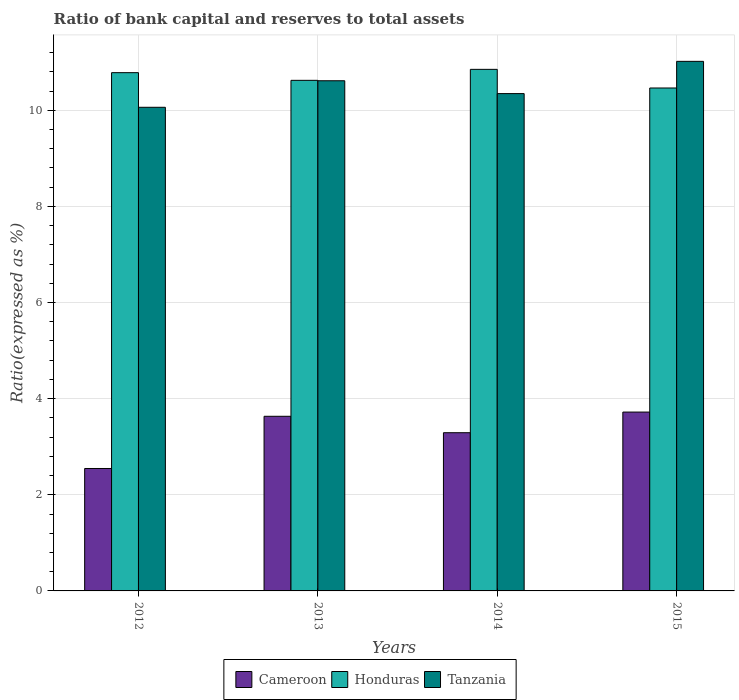How many different coloured bars are there?
Keep it short and to the point. 3. Are the number of bars per tick equal to the number of legend labels?
Ensure brevity in your answer.  Yes. How many bars are there on the 4th tick from the right?
Your answer should be compact. 3. What is the label of the 2nd group of bars from the left?
Offer a terse response. 2013. What is the ratio of bank capital and reserves to total assets in Honduras in 2014?
Provide a succinct answer. 10.85. Across all years, what is the maximum ratio of bank capital and reserves to total assets in Honduras?
Give a very brief answer. 10.85. Across all years, what is the minimum ratio of bank capital and reserves to total assets in Honduras?
Make the answer very short. 10.46. In which year was the ratio of bank capital and reserves to total assets in Tanzania maximum?
Make the answer very short. 2015. In which year was the ratio of bank capital and reserves to total assets in Honduras minimum?
Your answer should be very brief. 2015. What is the total ratio of bank capital and reserves to total assets in Cameroon in the graph?
Ensure brevity in your answer.  13.19. What is the difference between the ratio of bank capital and reserves to total assets in Honduras in 2012 and that in 2015?
Your response must be concise. 0.32. What is the difference between the ratio of bank capital and reserves to total assets in Cameroon in 2015 and the ratio of bank capital and reserves to total assets in Tanzania in 2014?
Offer a very short reply. -6.63. What is the average ratio of bank capital and reserves to total assets in Tanzania per year?
Your answer should be compact. 10.51. In the year 2012, what is the difference between the ratio of bank capital and reserves to total assets in Cameroon and ratio of bank capital and reserves to total assets in Honduras?
Offer a terse response. -8.23. What is the ratio of the ratio of bank capital and reserves to total assets in Tanzania in 2013 to that in 2014?
Offer a terse response. 1.03. What is the difference between the highest and the second highest ratio of bank capital and reserves to total assets in Cameroon?
Ensure brevity in your answer.  0.09. What is the difference between the highest and the lowest ratio of bank capital and reserves to total assets in Honduras?
Ensure brevity in your answer.  0.39. In how many years, is the ratio of bank capital and reserves to total assets in Honduras greater than the average ratio of bank capital and reserves to total assets in Honduras taken over all years?
Your answer should be compact. 2. What does the 1st bar from the left in 2014 represents?
Give a very brief answer. Cameroon. What does the 1st bar from the right in 2012 represents?
Offer a terse response. Tanzania. How many bars are there?
Provide a short and direct response. 12. Are the values on the major ticks of Y-axis written in scientific E-notation?
Offer a terse response. No. Does the graph contain any zero values?
Offer a terse response. No. Where does the legend appear in the graph?
Your answer should be compact. Bottom center. How are the legend labels stacked?
Your answer should be compact. Horizontal. What is the title of the graph?
Give a very brief answer. Ratio of bank capital and reserves to total assets. What is the label or title of the Y-axis?
Provide a short and direct response. Ratio(expressed as %). What is the Ratio(expressed as %) of Cameroon in 2012?
Make the answer very short. 2.55. What is the Ratio(expressed as %) in Honduras in 2012?
Offer a very short reply. 10.78. What is the Ratio(expressed as %) of Tanzania in 2012?
Offer a very short reply. 10.06. What is the Ratio(expressed as %) in Cameroon in 2013?
Provide a succinct answer. 3.63. What is the Ratio(expressed as %) in Honduras in 2013?
Your response must be concise. 10.62. What is the Ratio(expressed as %) of Tanzania in 2013?
Your answer should be compact. 10.61. What is the Ratio(expressed as %) of Cameroon in 2014?
Your answer should be very brief. 3.29. What is the Ratio(expressed as %) in Honduras in 2014?
Give a very brief answer. 10.85. What is the Ratio(expressed as %) in Tanzania in 2014?
Your answer should be compact. 10.35. What is the Ratio(expressed as %) in Cameroon in 2015?
Provide a short and direct response. 3.72. What is the Ratio(expressed as %) in Honduras in 2015?
Offer a terse response. 10.46. What is the Ratio(expressed as %) of Tanzania in 2015?
Offer a very short reply. 11.02. Across all years, what is the maximum Ratio(expressed as %) of Cameroon?
Give a very brief answer. 3.72. Across all years, what is the maximum Ratio(expressed as %) of Honduras?
Offer a terse response. 10.85. Across all years, what is the maximum Ratio(expressed as %) in Tanzania?
Provide a succinct answer. 11.02. Across all years, what is the minimum Ratio(expressed as %) of Cameroon?
Make the answer very short. 2.55. Across all years, what is the minimum Ratio(expressed as %) in Honduras?
Provide a short and direct response. 10.46. Across all years, what is the minimum Ratio(expressed as %) in Tanzania?
Provide a succinct answer. 10.06. What is the total Ratio(expressed as %) in Cameroon in the graph?
Keep it short and to the point. 13.19. What is the total Ratio(expressed as %) of Honduras in the graph?
Make the answer very short. 42.72. What is the total Ratio(expressed as %) in Tanzania in the graph?
Provide a short and direct response. 42.04. What is the difference between the Ratio(expressed as %) of Cameroon in 2012 and that in 2013?
Your answer should be compact. -1.09. What is the difference between the Ratio(expressed as %) in Honduras in 2012 and that in 2013?
Your response must be concise. 0.16. What is the difference between the Ratio(expressed as %) in Tanzania in 2012 and that in 2013?
Make the answer very short. -0.55. What is the difference between the Ratio(expressed as %) of Cameroon in 2012 and that in 2014?
Provide a short and direct response. -0.74. What is the difference between the Ratio(expressed as %) in Honduras in 2012 and that in 2014?
Ensure brevity in your answer.  -0.07. What is the difference between the Ratio(expressed as %) of Tanzania in 2012 and that in 2014?
Ensure brevity in your answer.  -0.28. What is the difference between the Ratio(expressed as %) of Cameroon in 2012 and that in 2015?
Keep it short and to the point. -1.17. What is the difference between the Ratio(expressed as %) in Honduras in 2012 and that in 2015?
Your response must be concise. 0.32. What is the difference between the Ratio(expressed as %) of Tanzania in 2012 and that in 2015?
Your response must be concise. -0.96. What is the difference between the Ratio(expressed as %) of Cameroon in 2013 and that in 2014?
Provide a succinct answer. 0.34. What is the difference between the Ratio(expressed as %) of Honduras in 2013 and that in 2014?
Provide a short and direct response. -0.23. What is the difference between the Ratio(expressed as %) of Tanzania in 2013 and that in 2014?
Your answer should be compact. 0.27. What is the difference between the Ratio(expressed as %) in Cameroon in 2013 and that in 2015?
Offer a very short reply. -0.09. What is the difference between the Ratio(expressed as %) of Honduras in 2013 and that in 2015?
Keep it short and to the point. 0.16. What is the difference between the Ratio(expressed as %) in Tanzania in 2013 and that in 2015?
Your response must be concise. -0.4. What is the difference between the Ratio(expressed as %) of Cameroon in 2014 and that in 2015?
Give a very brief answer. -0.43. What is the difference between the Ratio(expressed as %) of Honduras in 2014 and that in 2015?
Your answer should be very brief. 0.39. What is the difference between the Ratio(expressed as %) of Tanzania in 2014 and that in 2015?
Your answer should be compact. -0.67. What is the difference between the Ratio(expressed as %) of Cameroon in 2012 and the Ratio(expressed as %) of Honduras in 2013?
Make the answer very short. -8.08. What is the difference between the Ratio(expressed as %) in Cameroon in 2012 and the Ratio(expressed as %) in Tanzania in 2013?
Provide a short and direct response. -8.07. What is the difference between the Ratio(expressed as %) of Honduras in 2012 and the Ratio(expressed as %) of Tanzania in 2013?
Ensure brevity in your answer.  0.17. What is the difference between the Ratio(expressed as %) of Cameroon in 2012 and the Ratio(expressed as %) of Honduras in 2014?
Your response must be concise. -8.3. What is the difference between the Ratio(expressed as %) in Cameroon in 2012 and the Ratio(expressed as %) in Tanzania in 2014?
Offer a terse response. -7.8. What is the difference between the Ratio(expressed as %) of Honduras in 2012 and the Ratio(expressed as %) of Tanzania in 2014?
Keep it short and to the point. 0.44. What is the difference between the Ratio(expressed as %) of Cameroon in 2012 and the Ratio(expressed as %) of Honduras in 2015?
Give a very brief answer. -7.92. What is the difference between the Ratio(expressed as %) of Cameroon in 2012 and the Ratio(expressed as %) of Tanzania in 2015?
Offer a terse response. -8.47. What is the difference between the Ratio(expressed as %) of Honduras in 2012 and the Ratio(expressed as %) of Tanzania in 2015?
Provide a succinct answer. -0.24. What is the difference between the Ratio(expressed as %) of Cameroon in 2013 and the Ratio(expressed as %) of Honduras in 2014?
Give a very brief answer. -7.22. What is the difference between the Ratio(expressed as %) of Cameroon in 2013 and the Ratio(expressed as %) of Tanzania in 2014?
Ensure brevity in your answer.  -6.71. What is the difference between the Ratio(expressed as %) in Honduras in 2013 and the Ratio(expressed as %) in Tanzania in 2014?
Your answer should be very brief. 0.28. What is the difference between the Ratio(expressed as %) in Cameroon in 2013 and the Ratio(expressed as %) in Honduras in 2015?
Your answer should be compact. -6.83. What is the difference between the Ratio(expressed as %) of Cameroon in 2013 and the Ratio(expressed as %) of Tanzania in 2015?
Provide a succinct answer. -7.38. What is the difference between the Ratio(expressed as %) in Honduras in 2013 and the Ratio(expressed as %) in Tanzania in 2015?
Keep it short and to the point. -0.4. What is the difference between the Ratio(expressed as %) of Cameroon in 2014 and the Ratio(expressed as %) of Honduras in 2015?
Make the answer very short. -7.17. What is the difference between the Ratio(expressed as %) of Cameroon in 2014 and the Ratio(expressed as %) of Tanzania in 2015?
Ensure brevity in your answer.  -7.73. What is the difference between the Ratio(expressed as %) in Honduras in 2014 and the Ratio(expressed as %) in Tanzania in 2015?
Offer a very short reply. -0.17. What is the average Ratio(expressed as %) in Cameroon per year?
Offer a very short reply. 3.3. What is the average Ratio(expressed as %) in Honduras per year?
Your answer should be very brief. 10.68. What is the average Ratio(expressed as %) of Tanzania per year?
Give a very brief answer. 10.51. In the year 2012, what is the difference between the Ratio(expressed as %) of Cameroon and Ratio(expressed as %) of Honduras?
Your answer should be very brief. -8.23. In the year 2012, what is the difference between the Ratio(expressed as %) in Cameroon and Ratio(expressed as %) in Tanzania?
Your response must be concise. -7.51. In the year 2012, what is the difference between the Ratio(expressed as %) of Honduras and Ratio(expressed as %) of Tanzania?
Give a very brief answer. 0.72. In the year 2013, what is the difference between the Ratio(expressed as %) in Cameroon and Ratio(expressed as %) in Honduras?
Ensure brevity in your answer.  -6.99. In the year 2013, what is the difference between the Ratio(expressed as %) of Cameroon and Ratio(expressed as %) of Tanzania?
Ensure brevity in your answer.  -6.98. In the year 2013, what is the difference between the Ratio(expressed as %) of Honduras and Ratio(expressed as %) of Tanzania?
Provide a short and direct response. 0.01. In the year 2014, what is the difference between the Ratio(expressed as %) in Cameroon and Ratio(expressed as %) in Honduras?
Offer a very short reply. -7.56. In the year 2014, what is the difference between the Ratio(expressed as %) of Cameroon and Ratio(expressed as %) of Tanzania?
Keep it short and to the point. -7.05. In the year 2014, what is the difference between the Ratio(expressed as %) of Honduras and Ratio(expressed as %) of Tanzania?
Keep it short and to the point. 0.5. In the year 2015, what is the difference between the Ratio(expressed as %) of Cameroon and Ratio(expressed as %) of Honduras?
Make the answer very short. -6.74. In the year 2015, what is the difference between the Ratio(expressed as %) of Cameroon and Ratio(expressed as %) of Tanzania?
Your answer should be compact. -7.3. In the year 2015, what is the difference between the Ratio(expressed as %) of Honduras and Ratio(expressed as %) of Tanzania?
Ensure brevity in your answer.  -0.55. What is the ratio of the Ratio(expressed as %) of Cameroon in 2012 to that in 2013?
Your answer should be very brief. 0.7. What is the ratio of the Ratio(expressed as %) in Honduras in 2012 to that in 2013?
Ensure brevity in your answer.  1.01. What is the ratio of the Ratio(expressed as %) in Tanzania in 2012 to that in 2013?
Provide a short and direct response. 0.95. What is the ratio of the Ratio(expressed as %) of Cameroon in 2012 to that in 2014?
Keep it short and to the point. 0.77. What is the ratio of the Ratio(expressed as %) in Honduras in 2012 to that in 2014?
Keep it short and to the point. 0.99. What is the ratio of the Ratio(expressed as %) in Tanzania in 2012 to that in 2014?
Provide a short and direct response. 0.97. What is the ratio of the Ratio(expressed as %) in Cameroon in 2012 to that in 2015?
Your response must be concise. 0.68. What is the ratio of the Ratio(expressed as %) in Honduras in 2012 to that in 2015?
Offer a very short reply. 1.03. What is the ratio of the Ratio(expressed as %) of Tanzania in 2012 to that in 2015?
Ensure brevity in your answer.  0.91. What is the ratio of the Ratio(expressed as %) of Cameroon in 2013 to that in 2014?
Give a very brief answer. 1.1. What is the ratio of the Ratio(expressed as %) in Honduras in 2013 to that in 2014?
Your answer should be very brief. 0.98. What is the ratio of the Ratio(expressed as %) in Tanzania in 2013 to that in 2014?
Your answer should be very brief. 1.03. What is the ratio of the Ratio(expressed as %) of Cameroon in 2013 to that in 2015?
Your answer should be compact. 0.98. What is the ratio of the Ratio(expressed as %) of Honduras in 2013 to that in 2015?
Give a very brief answer. 1.02. What is the ratio of the Ratio(expressed as %) of Tanzania in 2013 to that in 2015?
Your answer should be very brief. 0.96. What is the ratio of the Ratio(expressed as %) of Cameroon in 2014 to that in 2015?
Ensure brevity in your answer.  0.88. What is the ratio of the Ratio(expressed as %) of Honduras in 2014 to that in 2015?
Keep it short and to the point. 1.04. What is the ratio of the Ratio(expressed as %) in Tanzania in 2014 to that in 2015?
Provide a succinct answer. 0.94. What is the difference between the highest and the second highest Ratio(expressed as %) of Cameroon?
Give a very brief answer. 0.09. What is the difference between the highest and the second highest Ratio(expressed as %) of Honduras?
Provide a short and direct response. 0.07. What is the difference between the highest and the second highest Ratio(expressed as %) of Tanzania?
Ensure brevity in your answer.  0.4. What is the difference between the highest and the lowest Ratio(expressed as %) in Cameroon?
Offer a terse response. 1.17. What is the difference between the highest and the lowest Ratio(expressed as %) in Honduras?
Offer a very short reply. 0.39. What is the difference between the highest and the lowest Ratio(expressed as %) of Tanzania?
Make the answer very short. 0.96. 